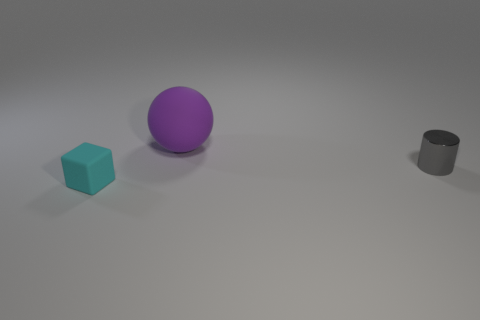Is there any indication of the size of these objects or what scale they are at? The image does not provide clear context for the absolute scale of the objects. However, their relative sizes can be inferred. The cube and cylinder appear to be roughly similar in height, while the sphere looks to be slightly larger than the other two. Without additional reference points, the exact dimensions remain ambiguous. 